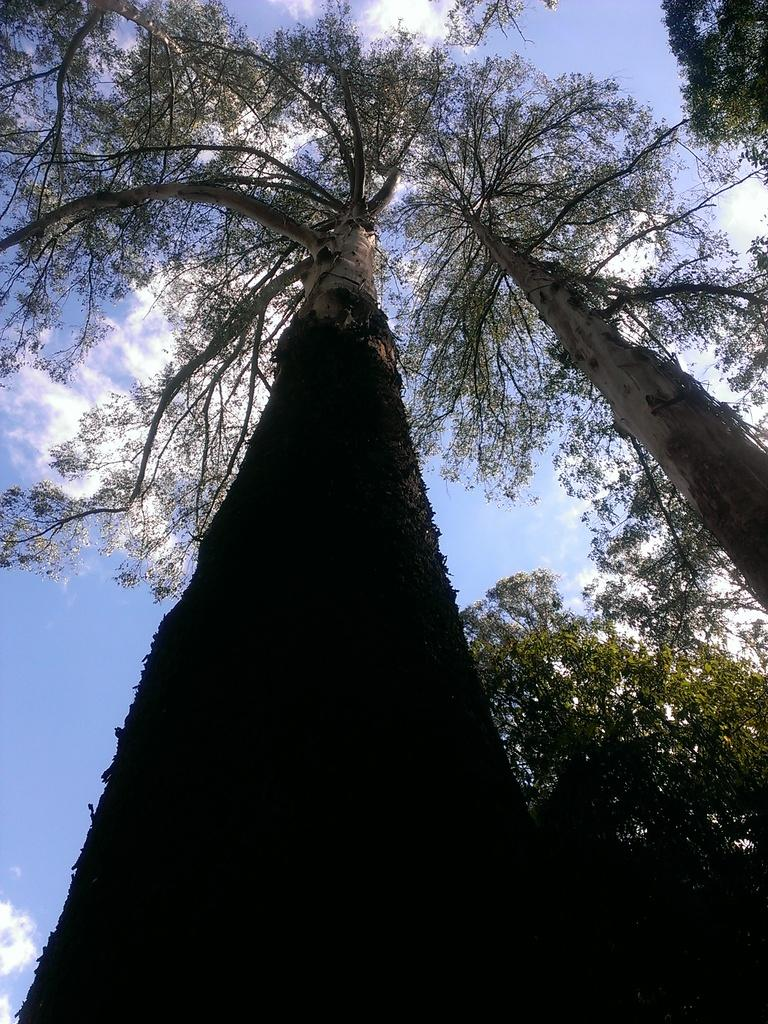What type of vegetation can be seen in the image? There are trees in the image. What is visible in the background of the image? There is a wall in the background of the image. What type of stick is the cow using to cover itself in the image? There is no stick, cow, or covering present in the image. 